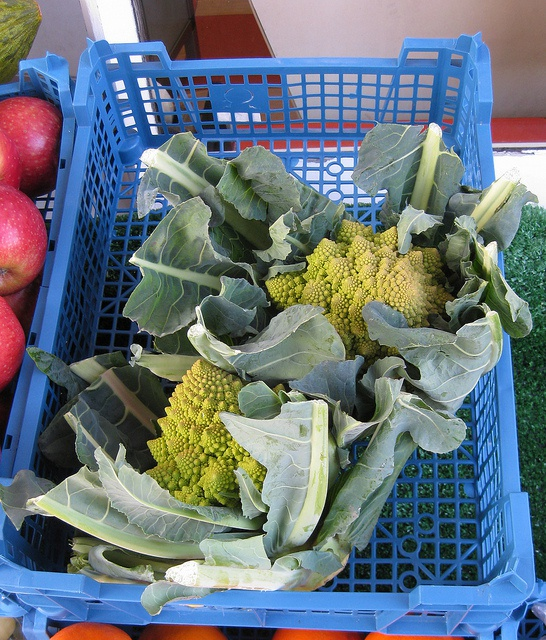Describe the objects in this image and their specific colors. I can see broccoli in olive and black tones, broccoli in olive, khaki, and black tones, apple in olive, salmon, black, maroon, and brown tones, apple in olive, salmon, and brown tones, and apple in olive, salmon, brown, and maroon tones in this image. 